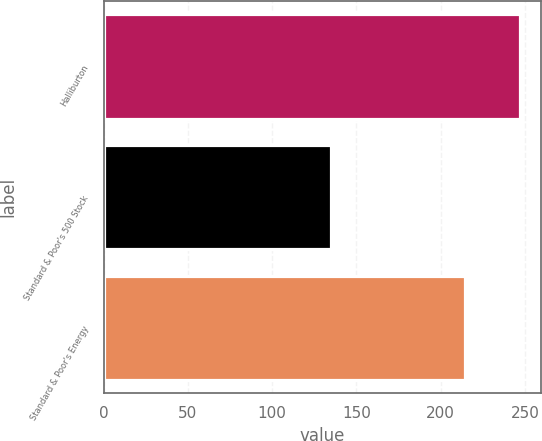Convert chart. <chart><loc_0><loc_0><loc_500><loc_500><bar_chart><fcel>Halliburton<fcel>Standard & Poor's 500 Stock<fcel>Standard & Poor's Energy<nl><fcel>247.14<fcel>134.7<fcel>214.63<nl></chart> 